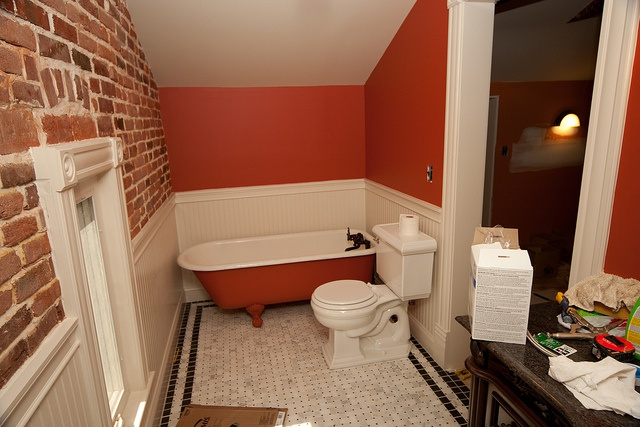Describe the objects in this image and their specific colors. I can see toilet in maroon, tan, and gray tones, book in maroon, darkgreen, black, olive, and darkgray tones, and bottle in maroon, olive, and gray tones in this image. 